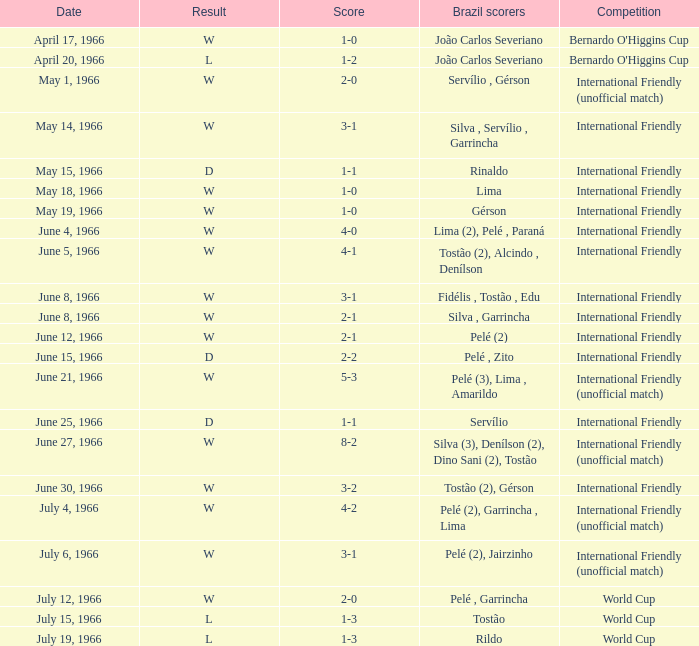Could you parse the entire table as a dict? {'header': ['Date', 'Result', 'Score', 'Brazil scorers', 'Competition'], 'rows': [['April 17, 1966', 'W', '1-0', 'João Carlos Severiano', "Bernardo O'Higgins Cup"], ['April 20, 1966', 'L', '1-2', 'João Carlos Severiano', "Bernardo O'Higgins Cup"], ['May 1, 1966', 'W', '2-0', 'Servílio , Gérson', 'International Friendly (unofficial match)'], ['May 14, 1966', 'W', '3-1', 'Silva , Servílio , Garrincha', 'International Friendly'], ['May 15, 1966', 'D', '1-1', 'Rinaldo', 'International Friendly'], ['May 18, 1966', 'W', '1-0', 'Lima', 'International Friendly'], ['May 19, 1966', 'W', '1-0', 'Gérson', 'International Friendly'], ['June 4, 1966', 'W', '4-0', 'Lima (2), Pelé , Paraná', 'International Friendly'], ['June 5, 1966', 'W', '4-1', 'Tostão (2), Alcindo , Denílson', 'International Friendly'], ['June 8, 1966', 'W', '3-1', 'Fidélis , Tostão , Edu', 'International Friendly'], ['June 8, 1966', 'W', '2-1', 'Silva , Garrincha', 'International Friendly'], ['June 12, 1966', 'W', '2-1', 'Pelé (2)', 'International Friendly'], ['June 15, 1966', 'D', '2-2', 'Pelé , Zito', 'International Friendly'], ['June 21, 1966', 'W', '5-3', 'Pelé (3), Lima , Amarildo', 'International Friendly (unofficial match)'], ['June 25, 1966', 'D', '1-1', 'Servílio', 'International Friendly'], ['June 27, 1966', 'W', '8-2', 'Silva (3), Denílson (2), Dino Sani (2), Tostão', 'International Friendly (unofficial match)'], ['June 30, 1966', 'W', '3-2', 'Tostão (2), Gérson', 'International Friendly'], ['July 4, 1966', 'W', '4-2', 'Pelé (2), Garrincha , Lima', 'International Friendly (unofficial match)'], ['July 6, 1966', 'W', '3-1', 'Pelé (2), Jairzinho', 'International Friendly (unofficial match)'], ['July 12, 1966', 'W', '2-0', 'Pelé , Garrincha', 'World Cup'], ['July 15, 1966', 'L', '1-3', 'Tostão', 'World Cup'], ['July 19, 1966', 'L', '1-3', 'Rildo', 'World Cup']]} What is the result of the International Friendly competition on May 15, 1966? D. 